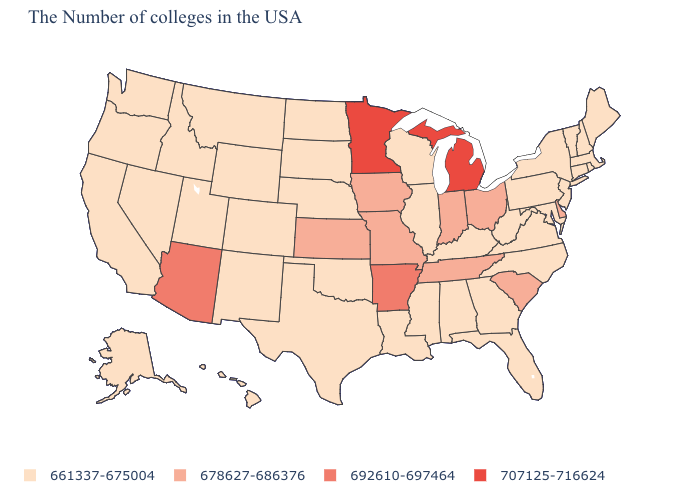Name the states that have a value in the range 678627-686376?
Keep it brief. Delaware, South Carolina, Ohio, Indiana, Tennessee, Missouri, Iowa, Kansas. What is the lowest value in the USA?
Write a very short answer. 661337-675004. Does Michigan have the highest value in the USA?
Write a very short answer. Yes. What is the value of Virginia?
Keep it brief. 661337-675004. What is the value of Montana?
Answer briefly. 661337-675004. Does Louisiana have the lowest value in the USA?
Write a very short answer. Yes. Name the states that have a value in the range 692610-697464?
Keep it brief. Arkansas, Arizona. Name the states that have a value in the range 661337-675004?
Short answer required. Maine, Massachusetts, Rhode Island, New Hampshire, Vermont, Connecticut, New York, New Jersey, Maryland, Pennsylvania, Virginia, North Carolina, West Virginia, Florida, Georgia, Kentucky, Alabama, Wisconsin, Illinois, Mississippi, Louisiana, Nebraska, Oklahoma, Texas, South Dakota, North Dakota, Wyoming, Colorado, New Mexico, Utah, Montana, Idaho, Nevada, California, Washington, Oregon, Alaska, Hawaii. What is the lowest value in the Northeast?
Keep it brief. 661337-675004. What is the value of Maine?
Be succinct. 661337-675004. Name the states that have a value in the range 692610-697464?
Answer briefly. Arkansas, Arizona. What is the value of South Dakota?
Be succinct. 661337-675004. Does Illinois have the same value as Massachusetts?
Quick response, please. Yes. What is the highest value in the South ?
Quick response, please. 692610-697464. 